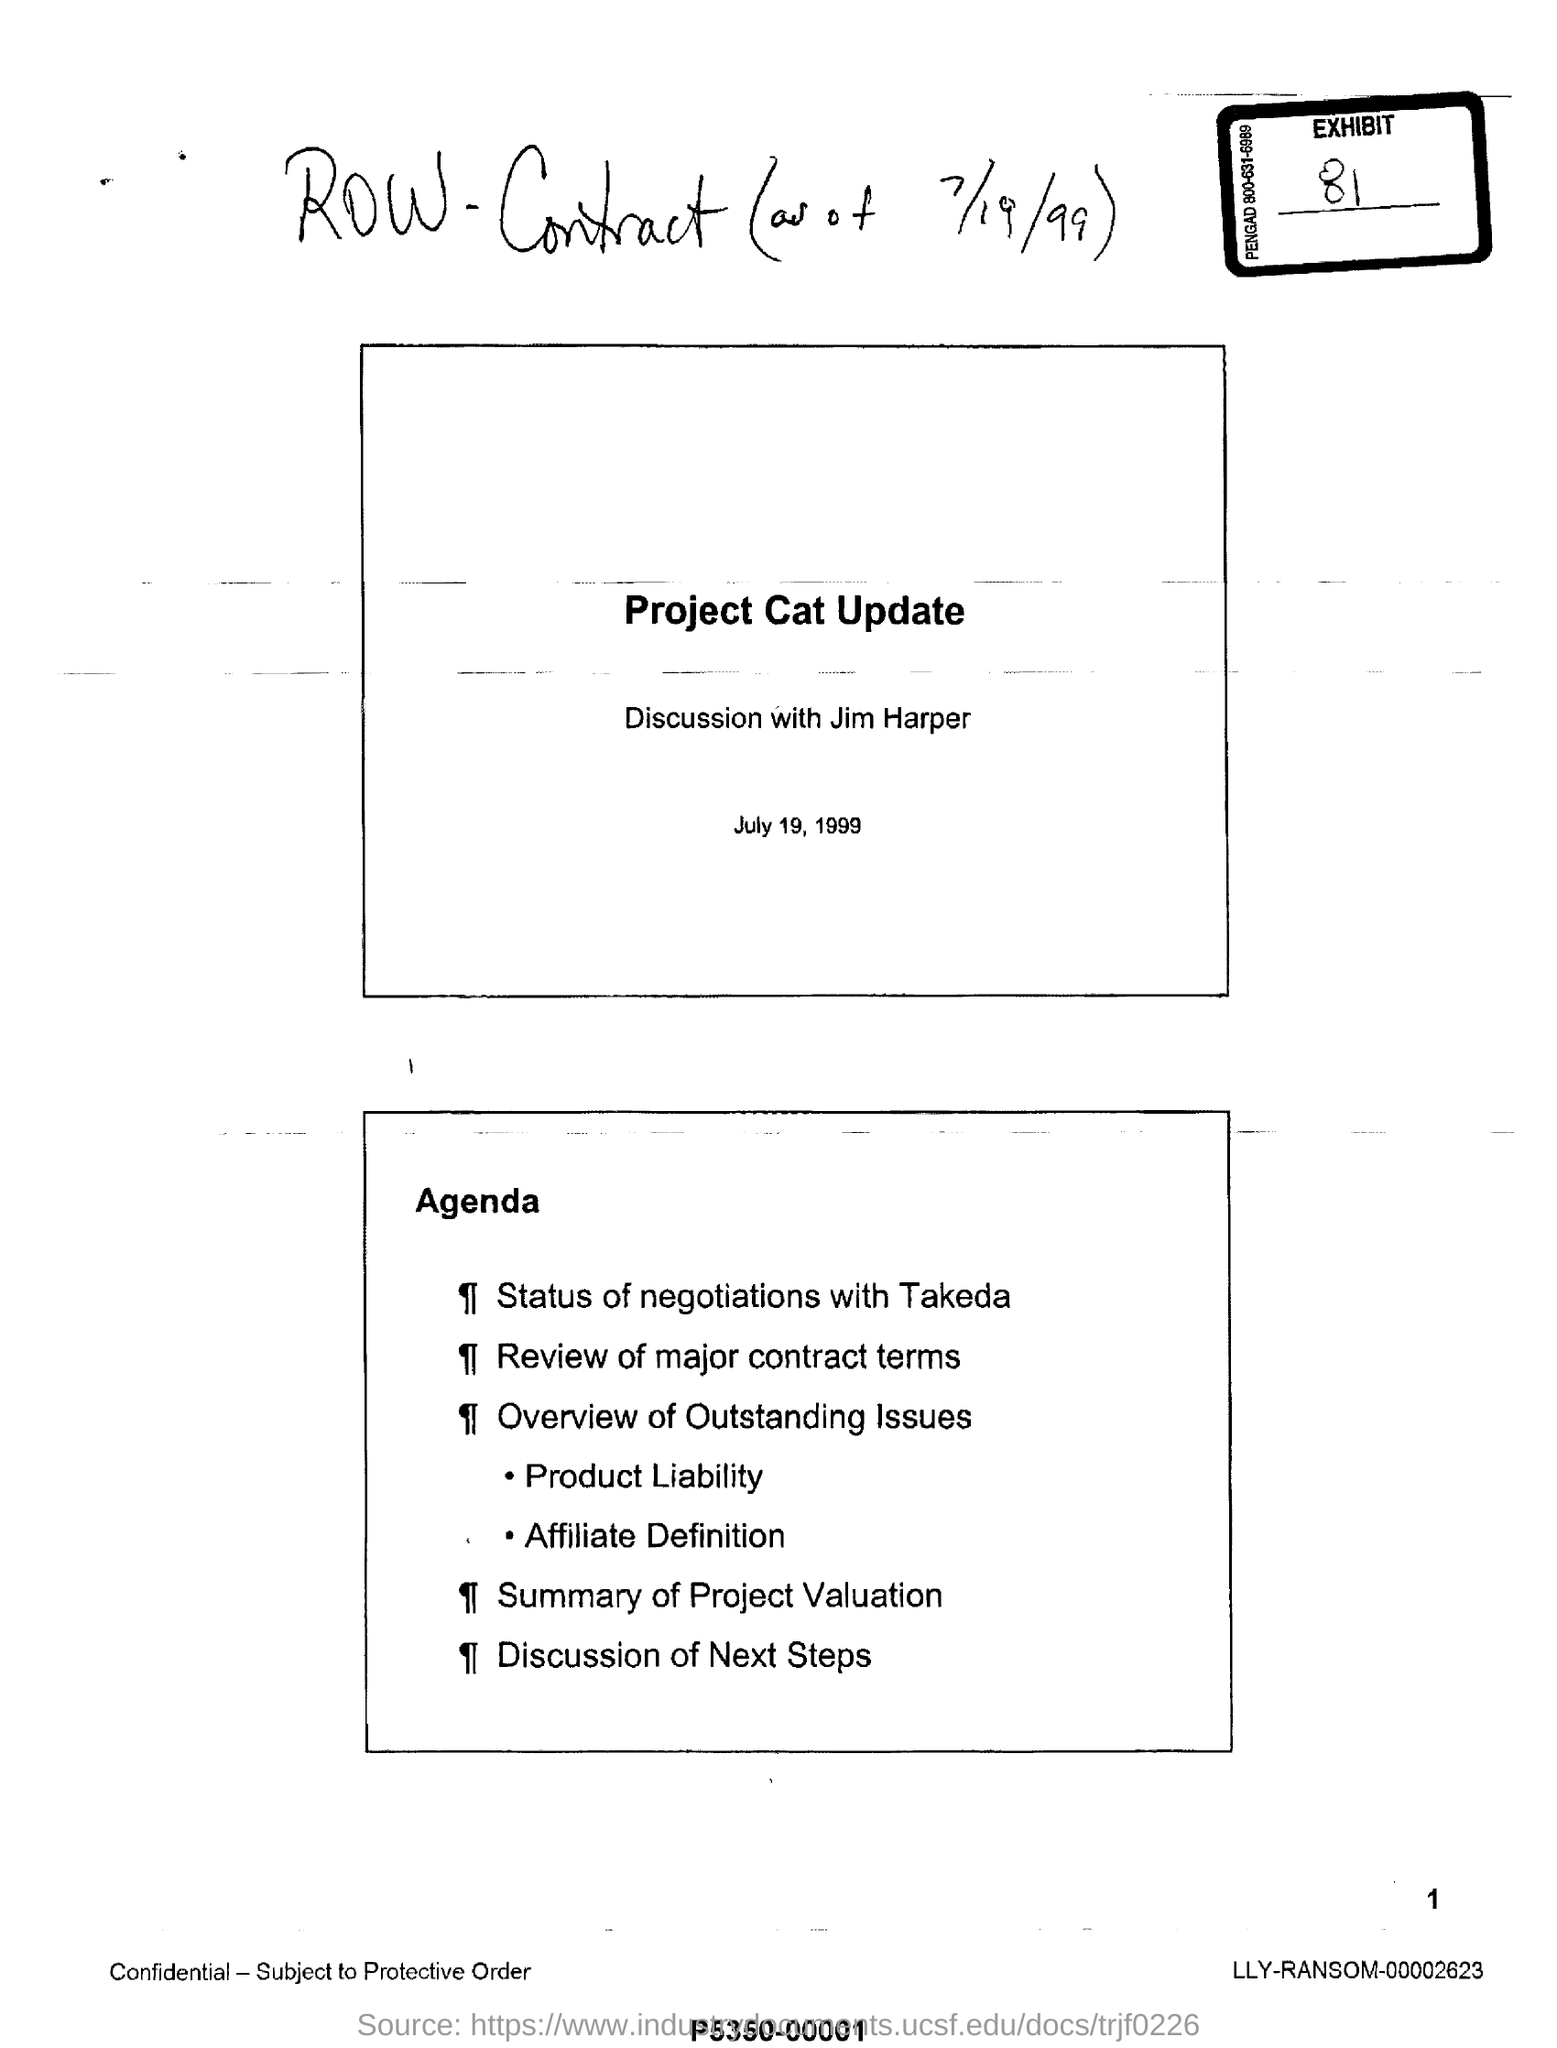What is the Handwritten sentence on the top?
Provide a short and direct response. Row-Contract (as of 7/19/99). What is the date mentioned?
Your answer should be very brief. JULY 19, 1999. With whom is the discussion being held?
Offer a terse response. JIM HARPER. 